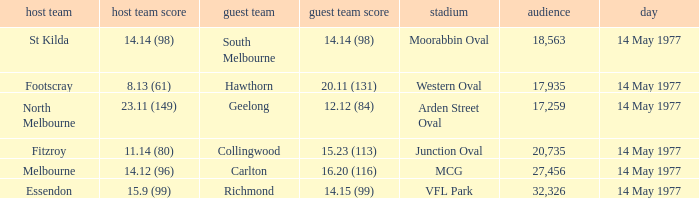How many people were in the crowd with the away team being collingwood? 1.0. 